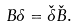Convert formula to latex. <formula><loc_0><loc_0><loc_500><loc_500>B \delta = \check { \delta } \check { B } .</formula> 